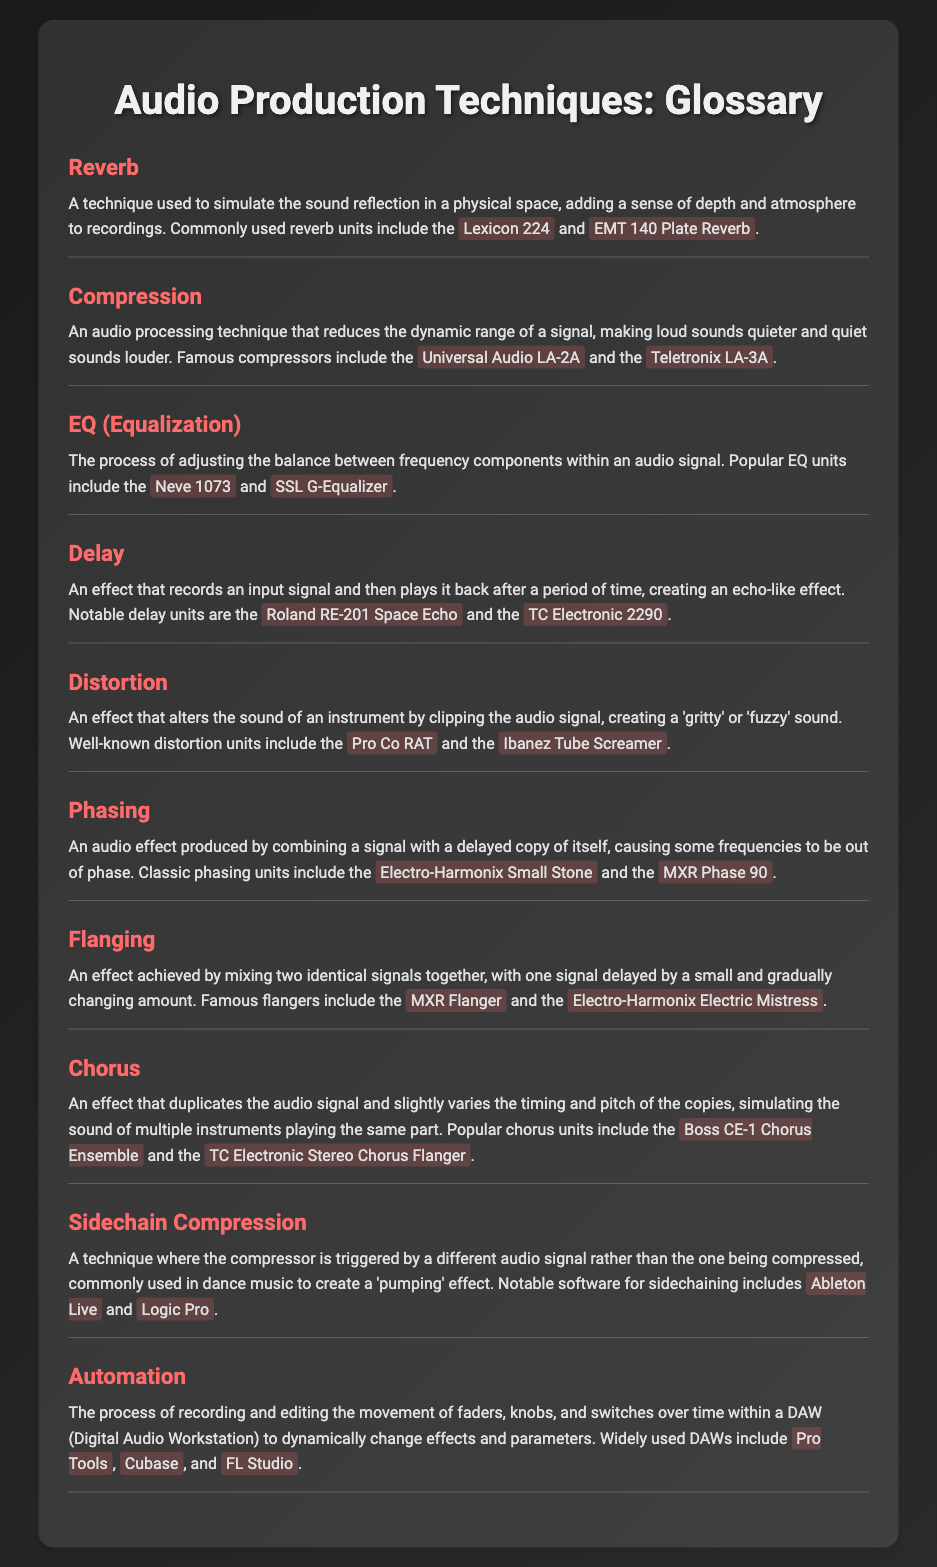What is the purpose of reverb? Reverb simulates sound reflection in a physical space, adding depth and atmosphere to recordings.
Answer: Simulating sound reflection Which compressor is mentioned as a famous unit? The document lists two famous compressors: Universal Audio LA-2A and Teletronix LA-3A.
Answer: Universal Audio LA-2A What audio effect creates an echo-like sound? The effect that records an input signal and plays it back after a delay is called delay.
Answer: Delay Which term is likely to simulate multiple instruments playing? The effect that duplicates an audio signal and varies the timing and pitch is called chorus.
Answer: Chorus What technique is commonly used to create a 'pumping' effect in dance music? This effect is achieved through sidechain compression, where the compressor is triggered by a different signal.
Answer: Sidechain Compression Name one notable software for sidechaining. The document lists Ableton Live and Logic Pro as notable software for sidechaining.
Answer: Ableton Live What is the role of automation in audio production? Automation records and edits the movement of faders, knobs, and switches to change effects and parameters dynamically.
Answer: Recording and editing movement Which two units are famous for phasing effects? The well-known phasing units listed are Electro-Harmonix Small Stone and MXR Phase 90.
Answer: Electro-Harmonix Small Stone What does distortion do to an audio signal? Distortion alters the sound by clipping the audio signal, creating a 'gritty' or 'fuzzy' sound.
Answer: Clipping the audio signal 